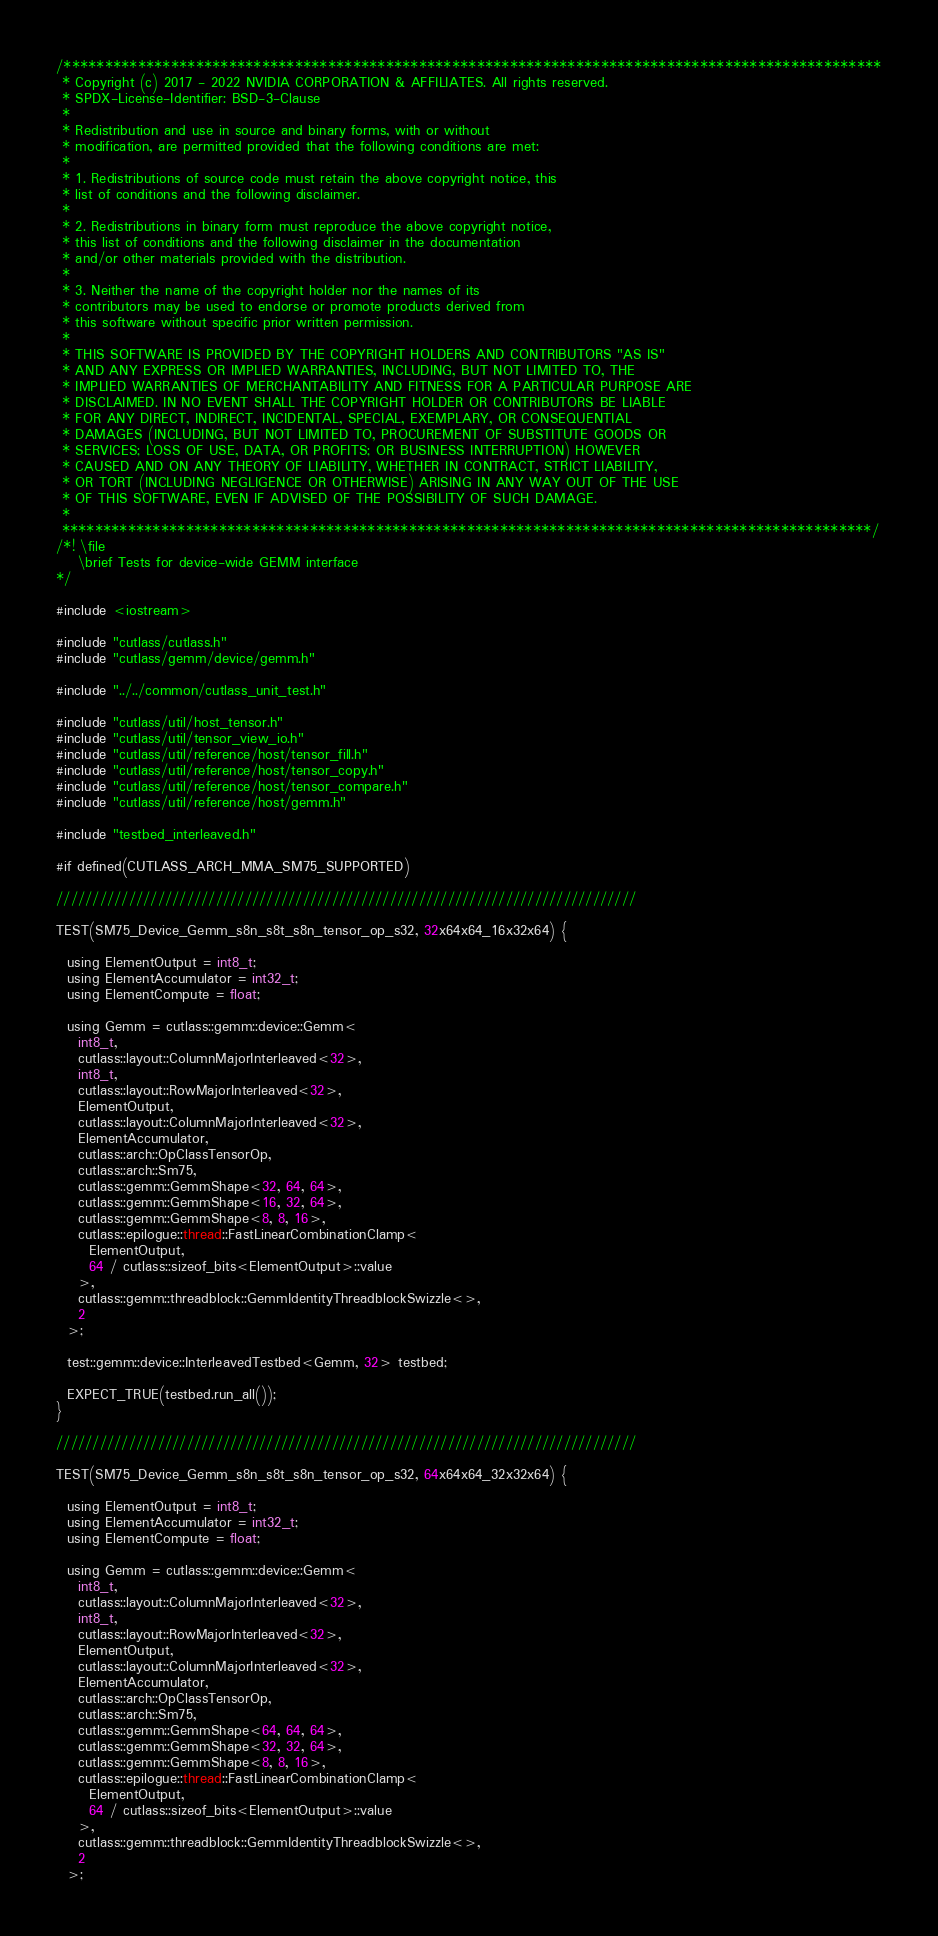Convert code to text. <code><loc_0><loc_0><loc_500><loc_500><_Cuda_>/***************************************************************************************************
 * Copyright (c) 2017 - 2022 NVIDIA CORPORATION & AFFILIATES. All rights reserved.
 * SPDX-License-Identifier: BSD-3-Clause
 *
 * Redistribution and use in source and binary forms, with or without
 * modification, are permitted provided that the following conditions are met:
 *
 * 1. Redistributions of source code must retain the above copyright notice, this
 * list of conditions and the following disclaimer.
 *
 * 2. Redistributions in binary form must reproduce the above copyright notice,
 * this list of conditions and the following disclaimer in the documentation
 * and/or other materials provided with the distribution.
 *
 * 3. Neither the name of the copyright holder nor the names of its
 * contributors may be used to endorse or promote products derived from
 * this software without specific prior written permission.
 *
 * THIS SOFTWARE IS PROVIDED BY THE COPYRIGHT HOLDERS AND CONTRIBUTORS "AS IS"
 * AND ANY EXPRESS OR IMPLIED WARRANTIES, INCLUDING, BUT NOT LIMITED TO, THE
 * IMPLIED WARRANTIES OF MERCHANTABILITY AND FITNESS FOR A PARTICULAR PURPOSE ARE
 * DISCLAIMED. IN NO EVENT SHALL THE COPYRIGHT HOLDER OR CONTRIBUTORS BE LIABLE
 * FOR ANY DIRECT, INDIRECT, INCIDENTAL, SPECIAL, EXEMPLARY, OR CONSEQUENTIAL
 * DAMAGES (INCLUDING, BUT NOT LIMITED TO, PROCUREMENT OF SUBSTITUTE GOODS OR
 * SERVICES; LOSS OF USE, DATA, OR PROFITS; OR BUSINESS INTERRUPTION) HOWEVER
 * CAUSED AND ON ANY THEORY OF LIABILITY, WHETHER IN CONTRACT, STRICT LIABILITY,
 * OR TORT (INCLUDING NEGLIGENCE OR OTHERWISE) ARISING IN ANY WAY OUT OF THE USE
 * OF THIS SOFTWARE, EVEN IF ADVISED OF THE POSSIBILITY OF SUCH DAMAGE.
 *
 **************************************************************************************************/
/*! \file
    \brief Tests for device-wide GEMM interface
*/

#include <iostream>

#include "cutlass/cutlass.h"
#include "cutlass/gemm/device/gemm.h"

#include "../../common/cutlass_unit_test.h"

#include "cutlass/util/host_tensor.h"
#include "cutlass/util/tensor_view_io.h"
#include "cutlass/util/reference/host/tensor_fill.h"
#include "cutlass/util/reference/host/tensor_copy.h"
#include "cutlass/util/reference/host/tensor_compare.h"
#include "cutlass/util/reference/host/gemm.h"

#include "testbed_interleaved.h"

#if defined(CUTLASS_ARCH_MMA_SM75_SUPPORTED)

////////////////////////////////////////////////////////////////////////////////

TEST(SM75_Device_Gemm_s8n_s8t_s8n_tensor_op_s32, 32x64x64_16x32x64) {

  using ElementOutput = int8_t;
  using ElementAccumulator = int32_t;
  using ElementCompute = float;

  using Gemm = cutlass::gemm::device::Gemm<
    int8_t,
    cutlass::layout::ColumnMajorInterleaved<32>,
    int8_t,
    cutlass::layout::RowMajorInterleaved<32>,
    ElementOutput,
    cutlass::layout::ColumnMajorInterleaved<32>,
    ElementAccumulator,
    cutlass::arch::OpClassTensorOp,
    cutlass::arch::Sm75,
    cutlass::gemm::GemmShape<32, 64, 64>,
    cutlass::gemm::GemmShape<16, 32, 64>,
    cutlass::gemm::GemmShape<8, 8, 16>,
    cutlass::epilogue::thread::FastLinearCombinationClamp<
      ElementOutput,
      64 / cutlass::sizeof_bits<ElementOutput>::value
    >,
    cutlass::gemm::threadblock::GemmIdentityThreadblockSwizzle<>,
    2
  >;

  test::gemm::device::InterleavedTestbed<Gemm, 32> testbed;

  EXPECT_TRUE(testbed.run_all());
}

////////////////////////////////////////////////////////////////////////////////

TEST(SM75_Device_Gemm_s8n_s8t_s8n_tensor_op_s32, 64x64x64_32x32x64) {

  using ElementOutput = int8_t;
  using ElementAccumulator = int32_t;
  using ElementCompute = float;

  using Gemm = cutlass::gemm::device::Gemm<
    int8_t,
    cutlass::layout::ColumnMajorInterleaved<32>,
    int8_t,
    cutlass::layout::RowMajorInterleaved<32>,
    ElementOutput,
    cutlass::layout::ColumnMajorInterleaved<32>,
    ElementAccumulator,
    cutlass::arch::OpClassTensorOp,
    cutlass::arch::Sm75,
    cutlass::gemm::GemmShape<64, 64, 64>,
    cutlass::gemm::GemmShape<32, 32, 64>,
    cutlass::gemm::GemmShape<8, 8, 16>,
    cutlass::epilogue::thread::FastLinearCombinationClamp<
      ElementOutput,
      64 / cutlass::sizeof_bits<ElementOutput>::value
    >,
    cutlass::gemm::threadblock::GemmIdentityThreadblockSwizzle<>,
    2
  >;
</code> 